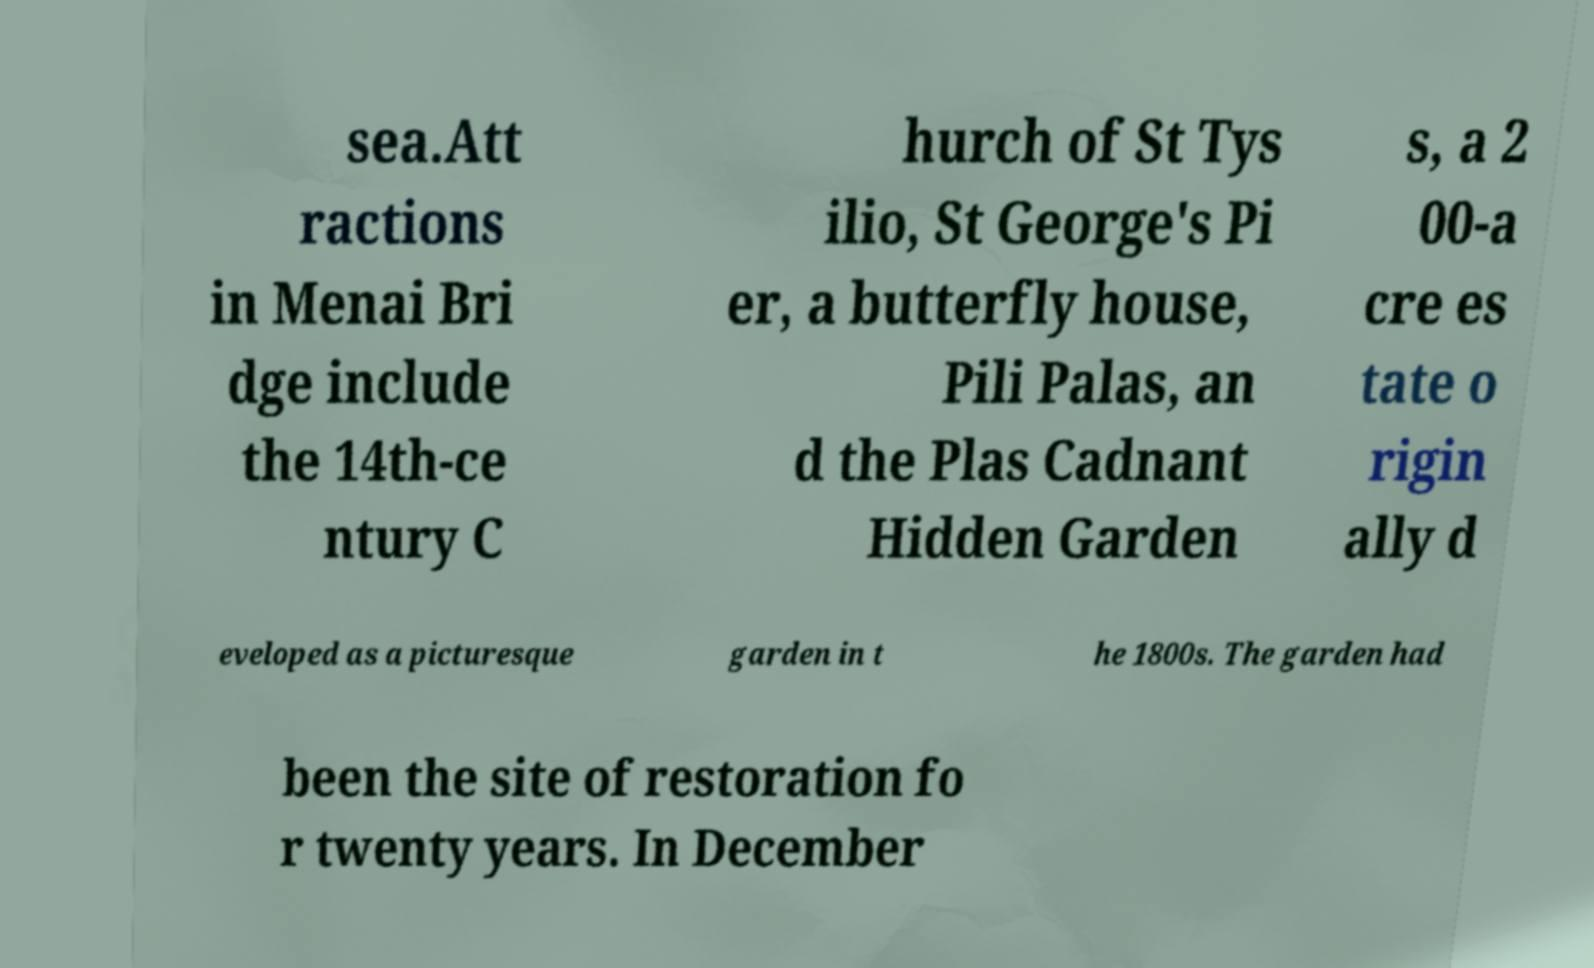Please read and relay the text visible in this image. What does it say? sea.Att ractions in Menai Bri dge include the 14th-ce ntury C hurch of St Tys ilio, St George's Pi er, a butterfly house, Pili Palas, an d the Plas Cadnant Hidden Garden s, a 2 00-a cre es tate o rigin ally d eveloped as a picturesque garden in t he 1800s. The garden had been the site of restoration fo r twenty years. In December 